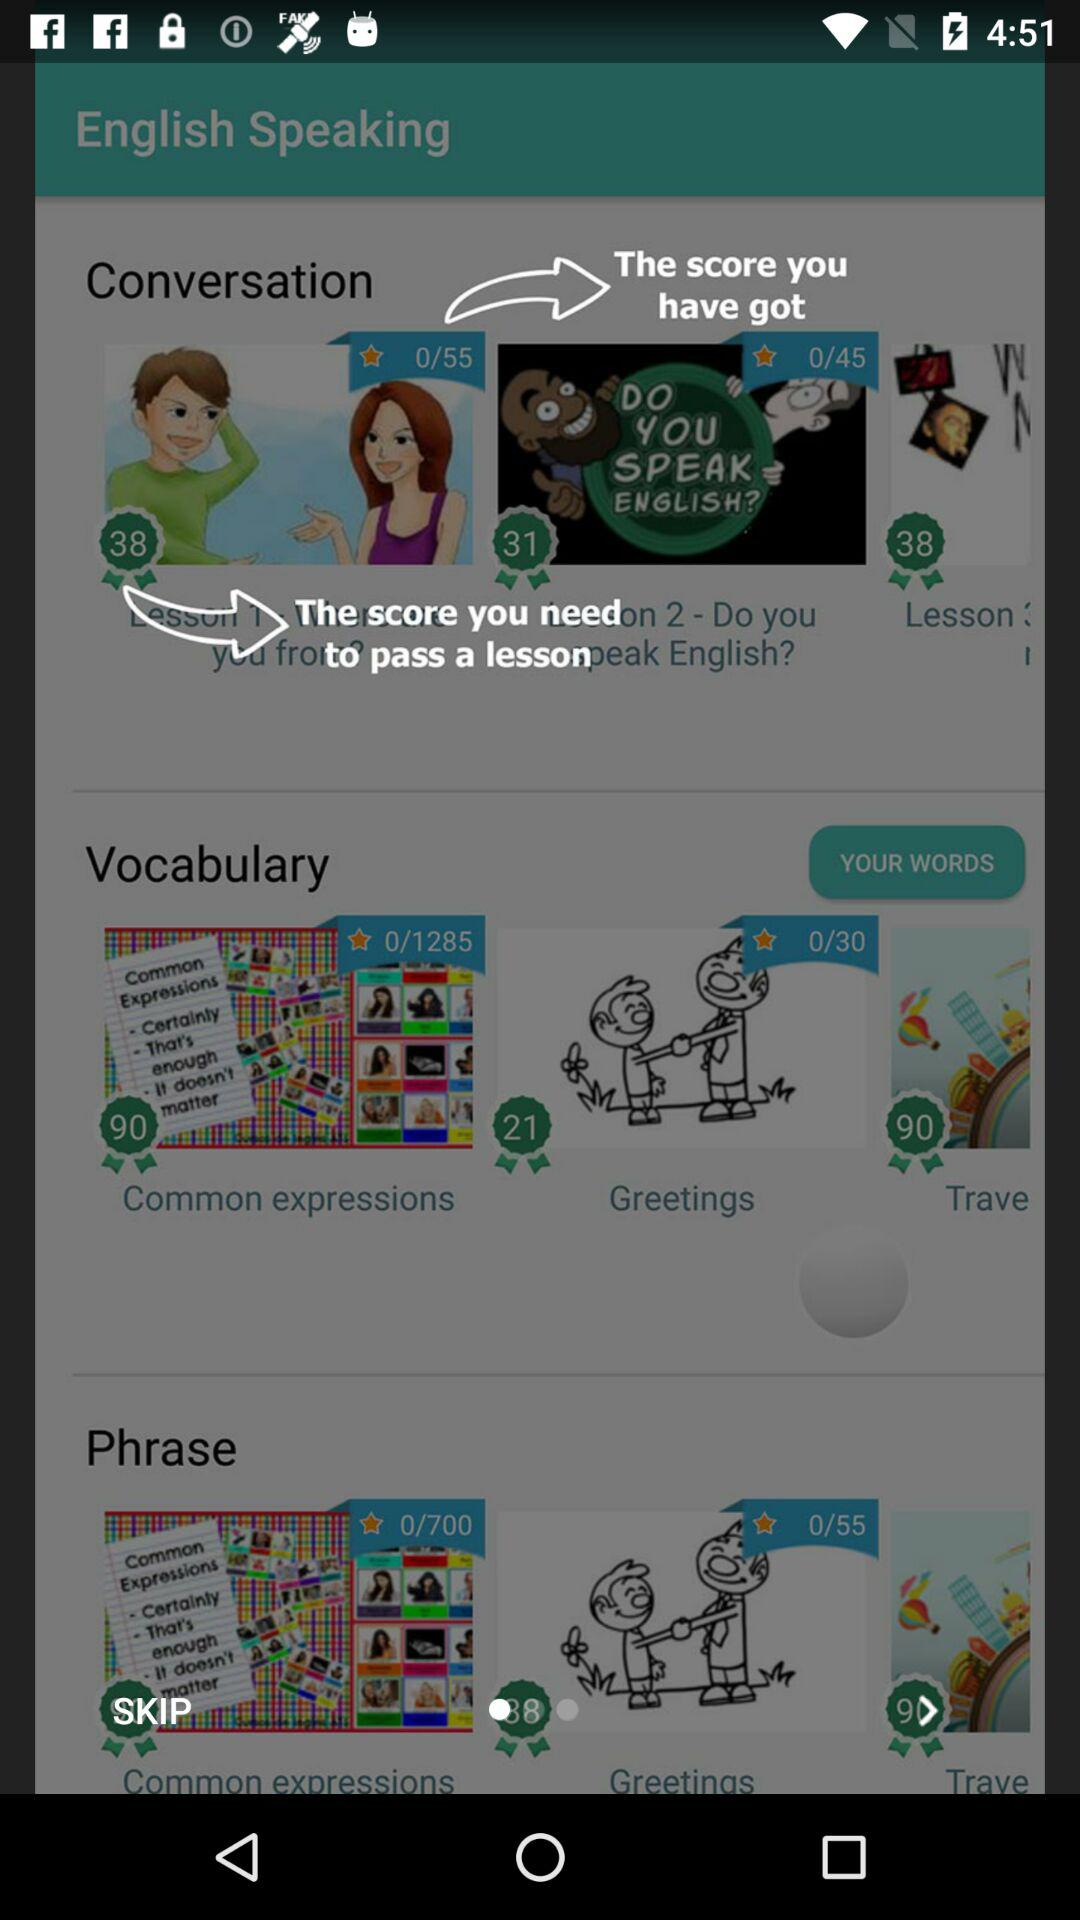How many lessons are there in total?
Answer the question using a single word or phrase. 3 